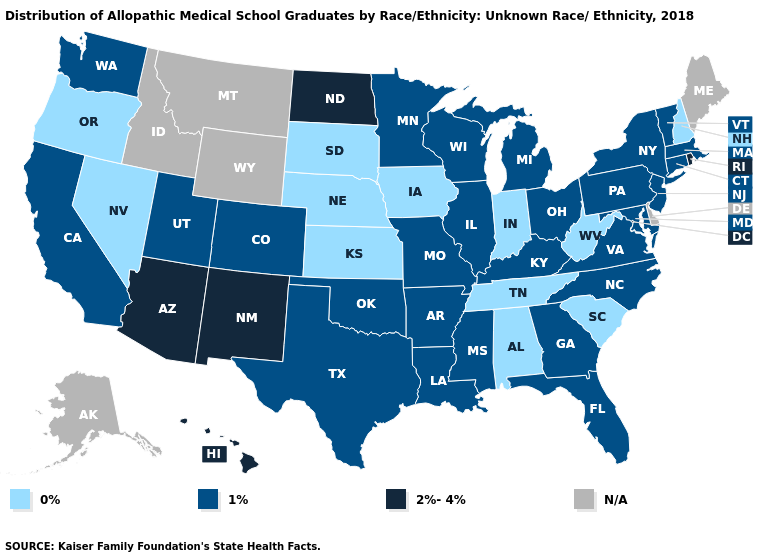What is the highest value in states that border North Carolina?
Give a very brief answer. 1%. Which states hav the highest value in the West?
Concise answer only. Arizona, Hawaii, New Mexico. What is the value of Iowa?
Short answer required. 0%. Name the states that have a value in the range N/A?
Be succinct. Alaska, Delaware, Idaho, Maine, Montana, Wyoming. Does Florida have the lowest value in the South?
Write a very short answer. No. Name the states that have a value in the range 1%?
Keep it brief. Arkansas, California, Colorado, Connecticut, Florida, Georgia, Illinois, Kentucky, Louisiana, Maryland, Massachusetts, Michigan, Minnesota, Mississippi, Missouri, New Jersey, New York, North Carolina, Ohio, Oklahoma, Pennsylvania, Texas, Utah, Vermont, Virginia, Washington, Wisconsin. Name the states that have a value in the range 1%?
Write a very short answer. Arkansas, California, Colorado, Connecticut, Florida, Georgia, Illinois, Kentucky, Louisiana, Maryland, Massachusetts, Michigan, Minnesota, Mississippi, Missouri, New Jersey, New York, North Carolina, Ohio, Oklahoma, Pennsylvania, Texas, Utah, Vermont, Virginia, Washington, Wisconsin. What is the value of Louisiana?
Short answer required. 1%. Does Arizona have the highest value in the USA?
Be succinct. Yes. Name the states that have a value in the range 0%?
Give a very brief answer. Alabama, Indiana, Iowa, Kansas, Nebraska, Nevada, New Hampshire, Oregon, South Carolina, South Dakota, Tennessee, West Virginia. What is the value of Delaware?
Be succinct. N/A. What is the value of North Dakota?
Answer briefly. 2%-4%. What is the value of Ohio?
Answer briefly. 1%. How many symbols are there in the legend?
Give a very brief answer. 4. 